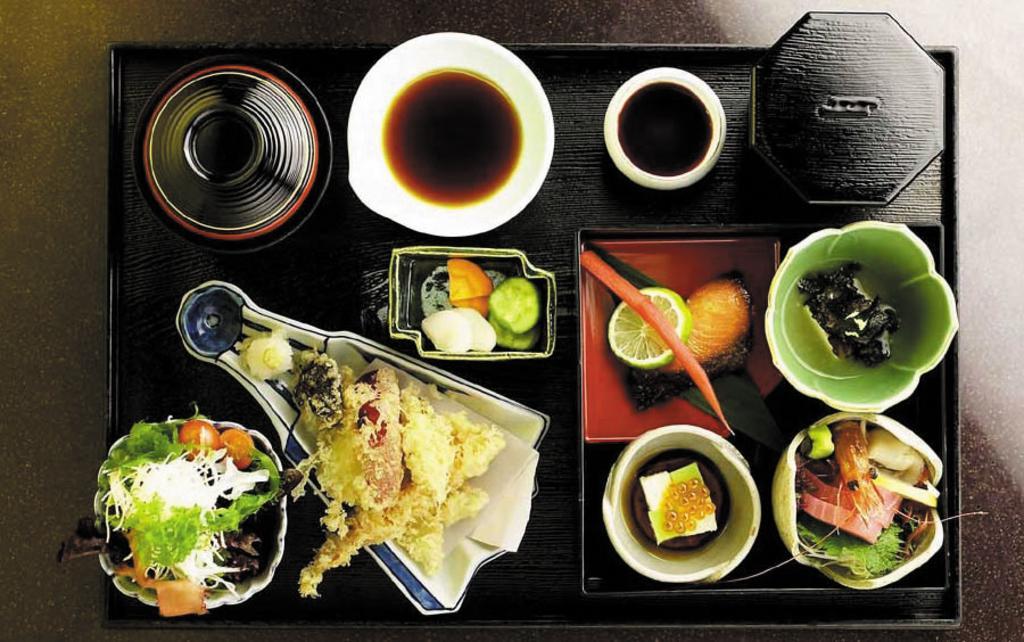In one or two sentences, can you explain what this image depicts? In this image we can see a tray on a surface. On the train there are bowls. In the bowels there are different types of food items. Also we can see a piece of lemon and some other things. 